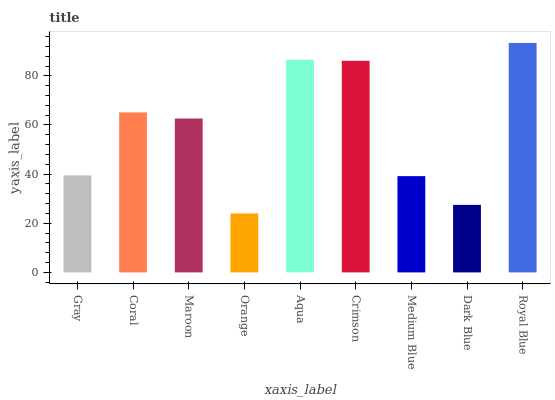Is Orange the minimum?
Answer yes or no. Yes. Is Royal Blue the maximum?
Answer yes or no. Yes. Is Coral the minimum?
Answer yes or no. No. Is Coral the maximum?
Answer yes or no. No. Is Coral greater than Gray?
Answer yes or no. Yes. Is Gray less than Coral?
Answer yes or no. Yes. Is Gray greater than Coral?
Answer yes or no. No. Is Coral less than Gray?
Answer yes or no. No. Is Maroon the high median?
Answer yes or no. Yes. Is Maroon the low median?
Answer yes or no. Yes. Is Gray the high median?
Answer yes or no. No. Is Royal Blue the low median?
Answer yes or no. No. 